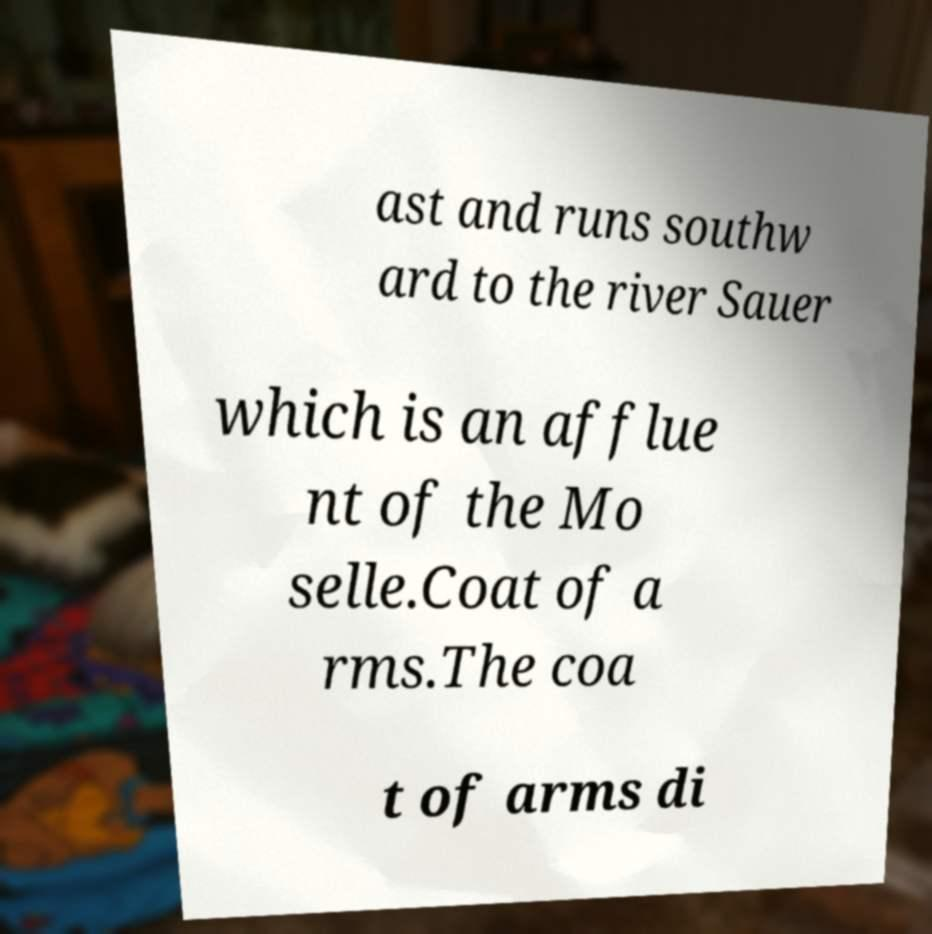Could you assist in decoding the text presented in this image and type it out clearly? ast and runs southw ard to the river Sauer which is an afflue nt of the Mo selle.Coat of a rms.The coa t of arms di 